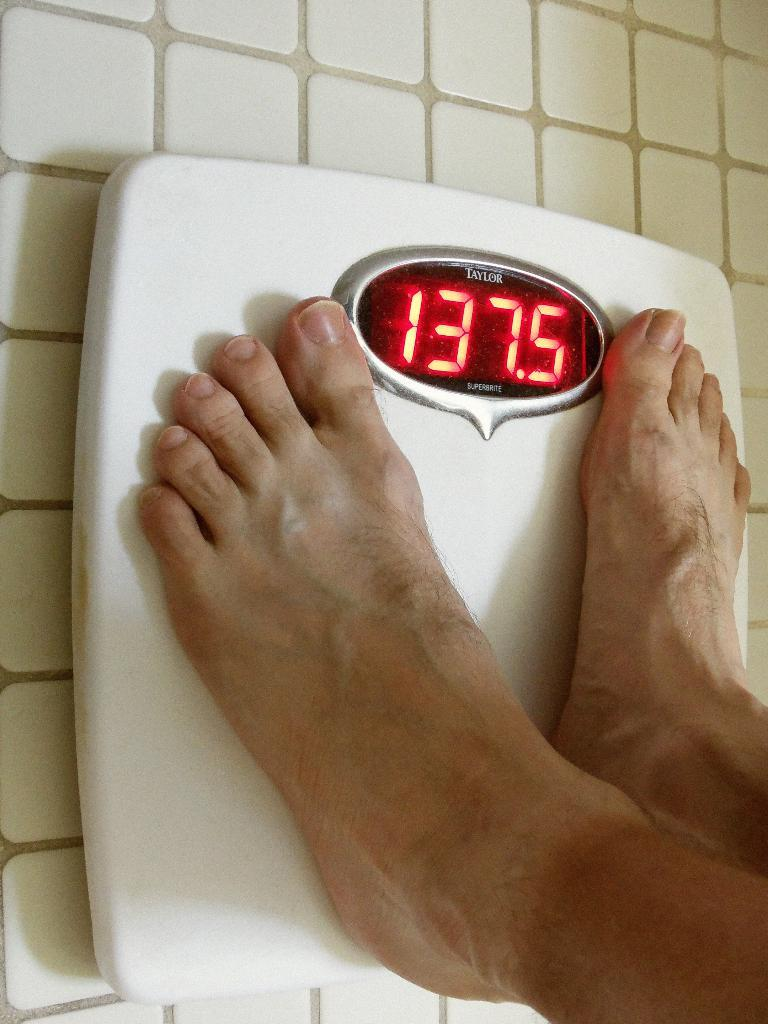What is the main subject of the image? There is a person in the image. What is the person doing in the image? The person is standing on a weighing machine. What type of bun is the person holding in the image? There is no bun present in the image; the person is standing on a weighing machine. Can you tell me the name of the stranger in the image? There is no stranger in the image; the person is the main subject. 